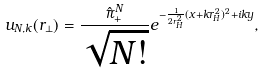Convert formula to latex. <formula><loc_0><loc_0><loc_500><loc_500>u _ { N , k } ( { r _ { \perp } } ) = \frac { \hat { \pi } _ { + } ^ { N } } { \sqrt { N ! } } e ^ { - \frac { 1 } { 2 r _ { H } ^ { 2 } } ( x + k r _ { H } ^ { 2 } ) ^ { 2 } + i k y } ,</formula> 